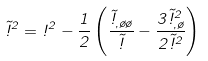Convert formula to latex. <formula><loc_0><loc_0><loc_500><loc_500>\tilde { \omega } ^ { 2 } = \omega ^ { 2 } - \frac { 1 } { 2 } \left ( \frac { \tilde { \omega } _ { , \tau \tau } } { \tilde { \omega } } - \frac { 3 \tilde { \omega } ^ { 2 } _ { , \tau } } { 2 \tilde { \omega } ^ { 2 } } \right )</formula> 